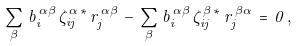Convert formula to latex. <formula><loc_0><loc_0><loc_500><loc_500>\sum _ { \beta } \, b ^ { \, \alpha \beta } _ { i } \, \zeta ^ { \, \alpha \, * } _ { i j } \, r ^ { \, \alpha \beta } _ { j } \, - \, \sum _ { \beta } \, b ^ { \, \alpha \beta } _ { i } \, \zeta ^ { \, \beta \, * } _ { i j } \, r ^ { \, \beta \alpha } _ { j } \, = \, 0 \, ,</formula> 